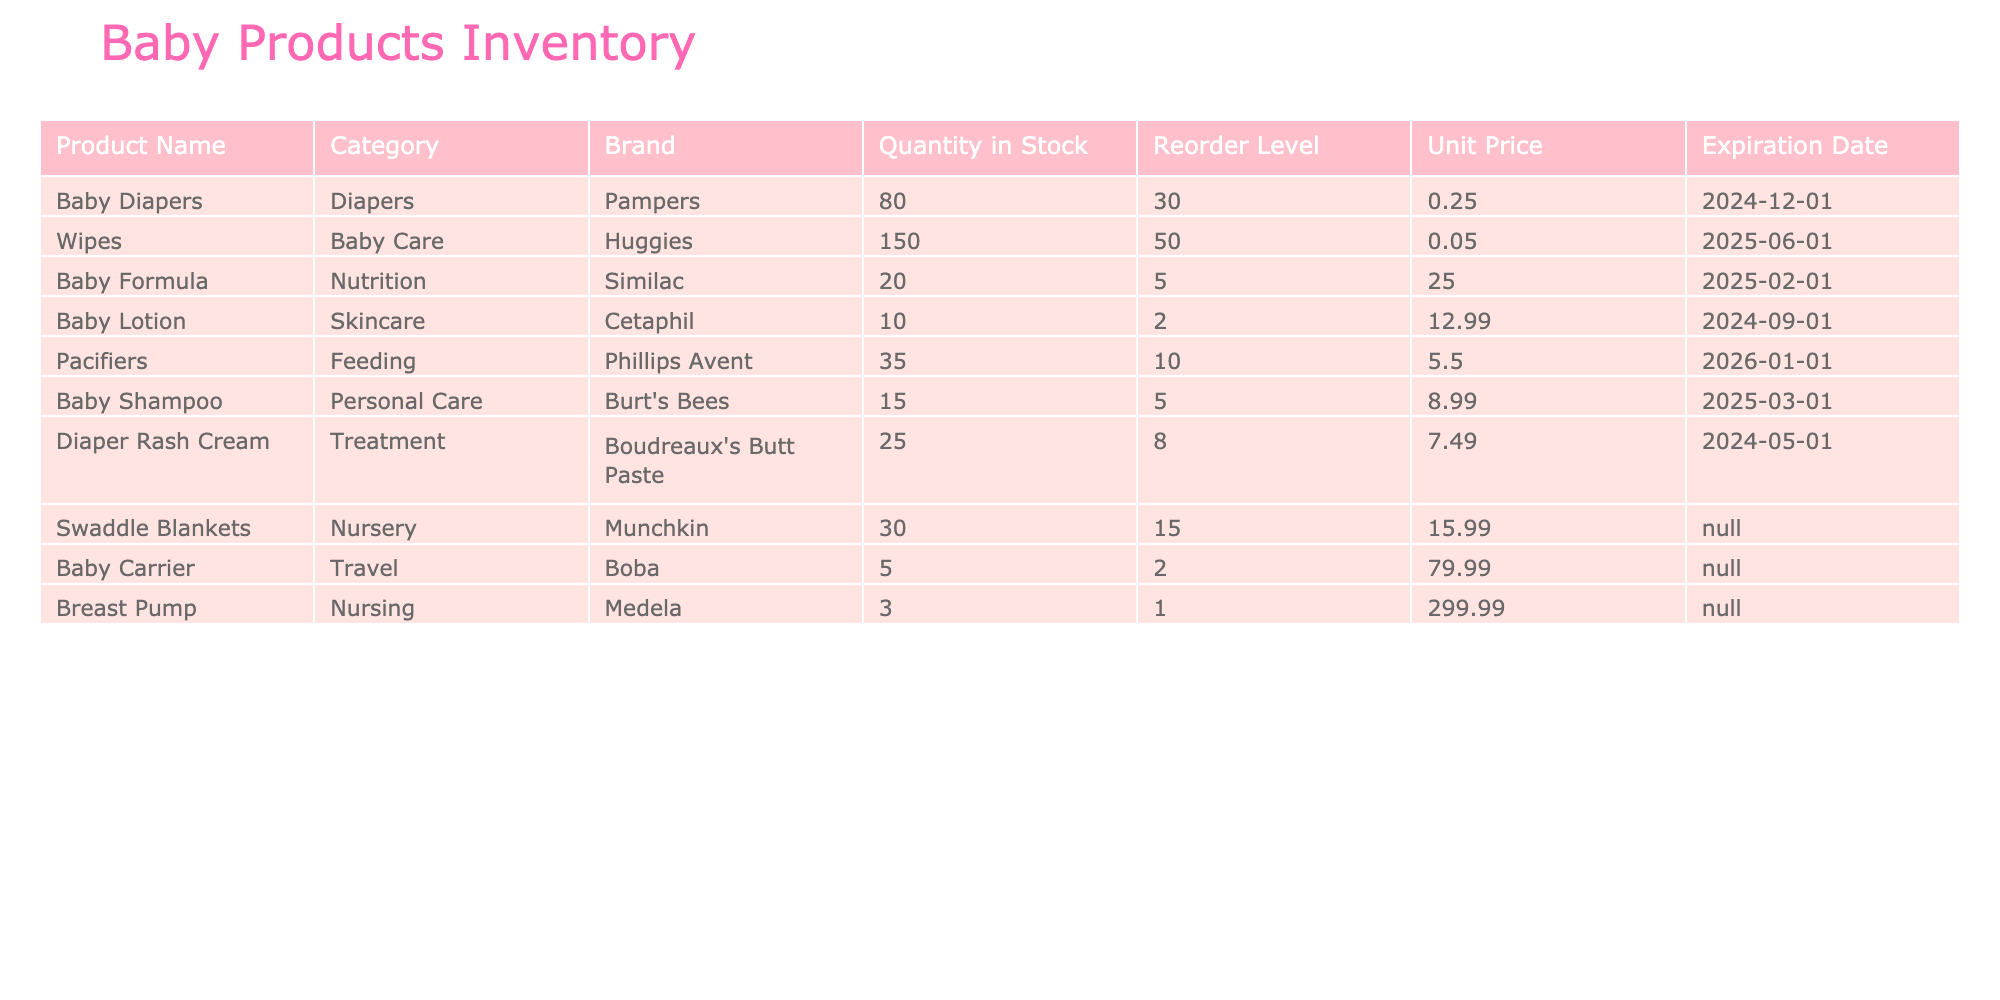What is the quantity in stock for Baby Diapers? The table shows a column for "Quantity in Stock" under the "Baby Diapers" row. The value listed is 80.
Answer: 80 What is the unit price of Baby Formula? The table lists the "Unit Price" for "Baby Formula" in its corresponding row, which is 25.00.
Answer: 25.00 Is the quantity in stock for Baby Lotion below the reorder level? The "Quantity in Stock" for Baby Lotion is 10, while the "Reorder Level" is 2. Since 10 is greater than 2, it is not below the reorder level.
Answer: No Which product has the highest unit price? By reviewing the "Unit Price" column, we find that the Breast Pump has the highest price at 299.99 compared to the other products listed.
Answer: Breast Pump What is the total quantity of products in stock that are below their reorder levels? The products with quantities below their reorder levels are Baby Lotion (10), Baby Carrier (5), and Breast Pump (3), totaling 18. This is calculated as 10 + 5 + 3 = 18.
Answer: 18 Are there any products that do not have an expiration date listed? By scanning the "Expiration Date" column, Swaddle Blankets and Baby Carrier do not have expiration dates listed (marked as N/A). Therefore, there are products without expiration dates.
Answer: Yes What is the average unit price of all the products? To find the average, sum the unit prices: (0.25 + 0.05 + 25.00 + 12.99 + 5.50 + 8.99 + 7.49 + 15.99 + 79.99 + 299.99) = 449.25. Then divide by the number of products (10). So, 449.25/10 = 44.93.
Answer: 44.93 How many products have a reorder level of 10 or more? Counting the products with a "Reorder Level" of 10 or more, we find Baby Diapers (30), Wipes (50), Baby Formula (5), Pacifiers (10), Diaper Rash Cream (8), and Breast Pump (1, but it is below) totals 6 products.
Answer: 6 What is the quantity of Wipes compared to the quantity of Baby Shampoo? The quantity of Wipes is 150, while Baby Shampoo has 15. This shows that there are 150 - 15 = 135 more Wipes than Baby Shampoo.
Answer: 135 